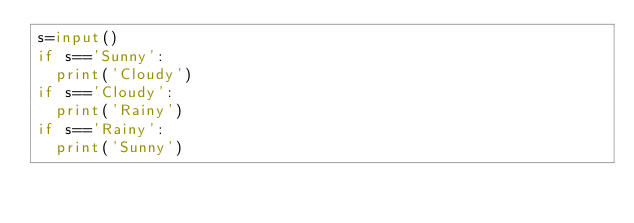<code> <loc_0><loc_0><loc_500><loc_500><_Python_>s=input()
if s=='Sunny':
  print('Cloudy')
if s=='Cloudy':
  print('Rainy')
if s=='Rainy':
  print('Sunny')</code> 